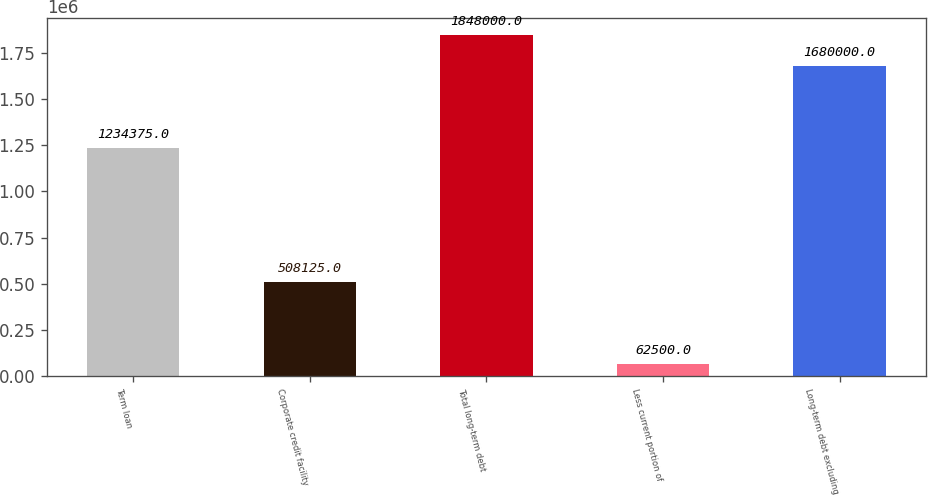Convert chart to OTSL. <chart><loc_0><loc_0><loc_500><loc_500><bar_chart><fcel>Term loan<fcel>Corporate credit facility<fcel>Total long-term debt<fcel>Less current portion of<fcel>Long-term debt excluding<nl><fcel>1.23438e+06<fcel>508125<fcel>1.848e+06<fcel>62500<fcel>1.68e+06<nl></chart> 